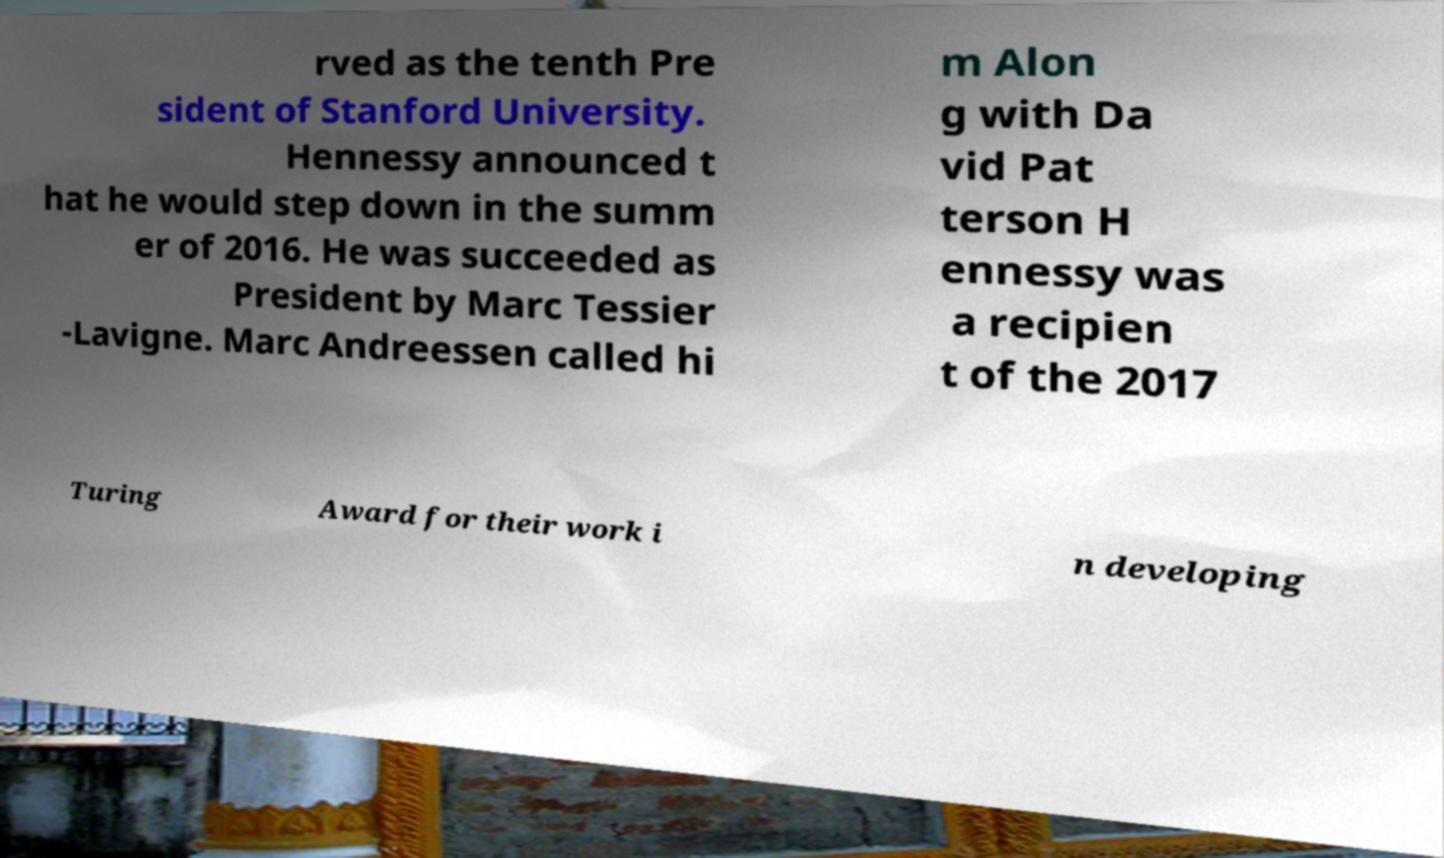Please identify and transcribe the text found in this image. rved as the tenth Pre sident of Stanford University. Hennessy announced t hat he would step down in the summ er of 2016. He was succeeded as President by Marc Tessier -Lavigne. Marc Andreessen called hi m Alon g with Da vid Pat terson H ennessy was a recipien t of the 2017 Turing Award for their work i n developing 